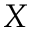Convert formula to latex. <formula><loc_0><loc_0><loc_500><loc_500>X</formula> 